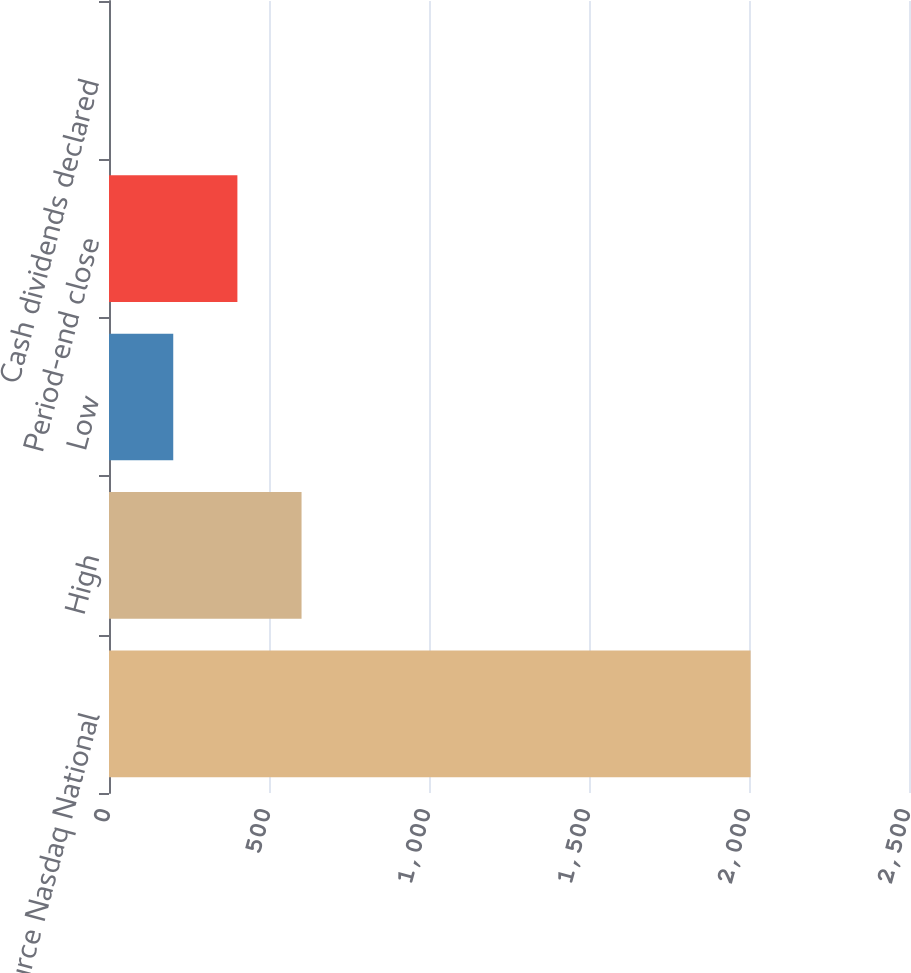Convert chart. <chart><loc_0><loc_0><loc_500><loc_500><bar_chart><fcel>(Source Nasdaq National<fcel>High<fcel>Low<fcel>Period-end close<fcel>Cash dividends declared<nl><fcel>2005<fcel>601.71<fcel>200.77<fcel>401.24<fcel>0.3<nl></chart> 